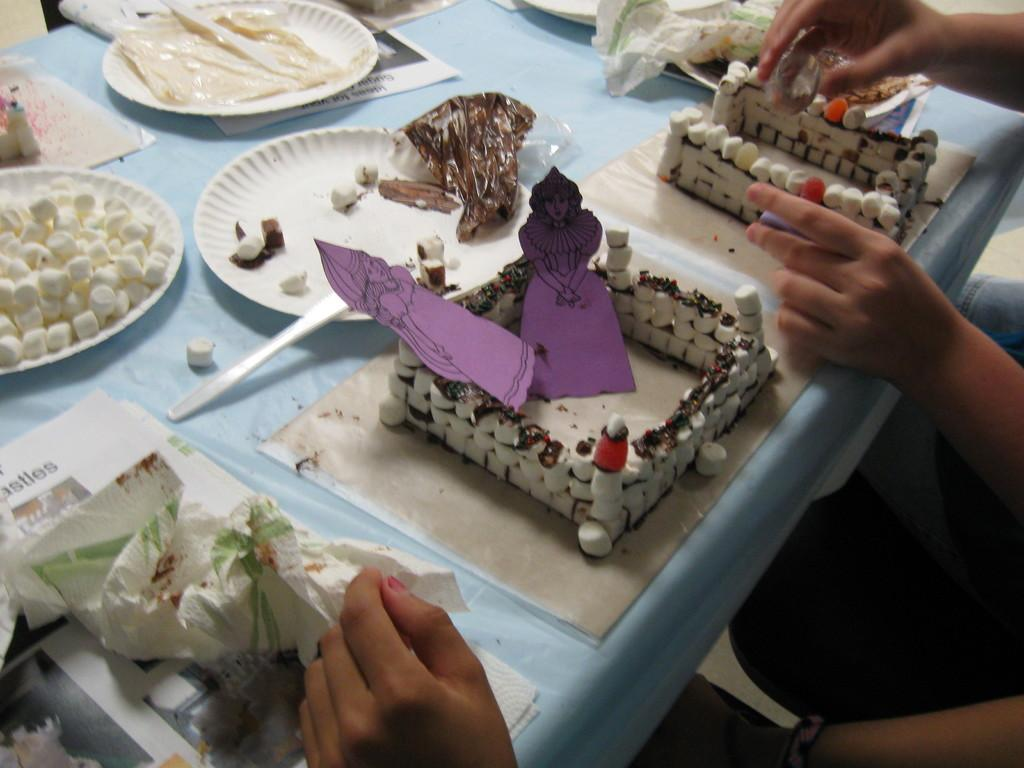What body parts are visible in the image? There are people's hands in the image. What type of furniture is present in the image? There is a table in the image. What items are used for eating in the image? There are plates and spoons in the image. What type of objects can be seen on the table? There are papers and covers in the image. What color dominates the objects in the image? There are white color objects in the image. What direction is the sign pointing to in the image? There is no sign present in the image. What type of advertisement can be seen on the table in the image? There is no advertisement present in the image. 